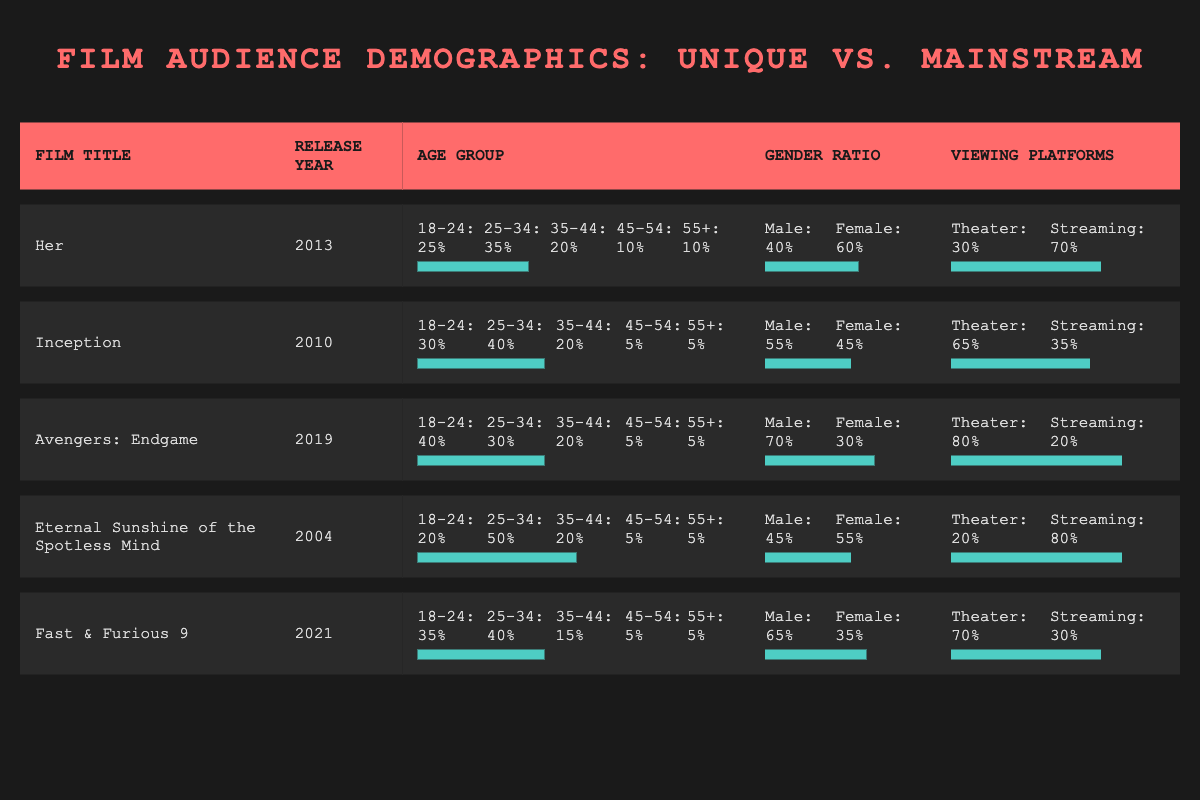What is the gender ratio of "Eternal Sunshine of the Spotless Mind"? The gender ratio is provided in the table for this film under the gender ratio section, showing Male: 45% and Female: 55%.
Answer: Male: 45%, Female: 55% Which film has the highest percentage of viewers aged 18-24? By comparing the age group data for all films, "Avengers: Endgame" has the highest percentage at 40% for the 18-24 age group.
Answer: "Avengers: Endgame" What is the average percentage of female viewers for unique storyline films? The unique storyline films are "Her," "Inception," and "Eternal Sunshine of the Spotless Mind," which have female viewer percentages of 60%, 45%, and 55%, respectively. Adding these up gives 60 + 45 + 55 = 160, and dividing by 3 gives an average of 160/3 = approximately 53.33%.
Answer: 53.33% Did "Inception" have a higher percentage of theater viewers compared to "Fast & Furious 9"? The viewing platforms for "Inception" show 65% in theaters while "Fast & Furious 9" shows 70% in theaters. Since 65% is less than 70%, "Inception" did not have a higher percentage of theater viewers.
Answer: No What is the difference in streaming viewer percentages between "Her" and "Avengers: Endgame"? "Her" has 70% streaming viewers, while "Avengers: Endgame" has 20%. The difference is 70 - 20 = 50%.
Answer: 50% What percentage of viewers aged 35-44 watched "Fast & Furious 9"? The age group data for "Fast & Furious 9" shows that 15% of viewers were aged 35-44.
Answer: 15% Which film has the least percentage of viewers in the 45-54 age group? Looking at the 45-54 age group for all films, "Inception" and both "Avengers: Endgame" and "Fast & Furious 9" have the same percentage of 5%. There are no films with lower percentages in this group.
Answer: "Inception," "Avengers: Endgame," and "Fast & Furious 9" (5% each) What is the total percentage of theater viewers across all unique storyline films? Summing the theater viewer percentages for unique storyline films: "Her" (30%) + "Inception" (65%) + "Eternal Sunshine of the Spotless Mind" (20%) = 115%.
Answer: 115% Which age group has the highest percentage of viewers for mainstream films? For mainstream films, "Avengers: Endgame" has 40% and "Fast & Furious 9" has 35% in the 18-24 age group. This is the highest percentage when considering both films, so the highest group is 18-24.
Answer: 18-24 Is there a trend of increasing theater viewer percentages for unique storyline films over the years? The theater percentages for unique storyline films are 30% for "Her" (2013), 65% for "Inception" (2010), and 20% for "Eternal Sunshine of the Spotless Mind" (2004). The percentage does not show an increasing trend; it fluctuates instead.
Answer: No 